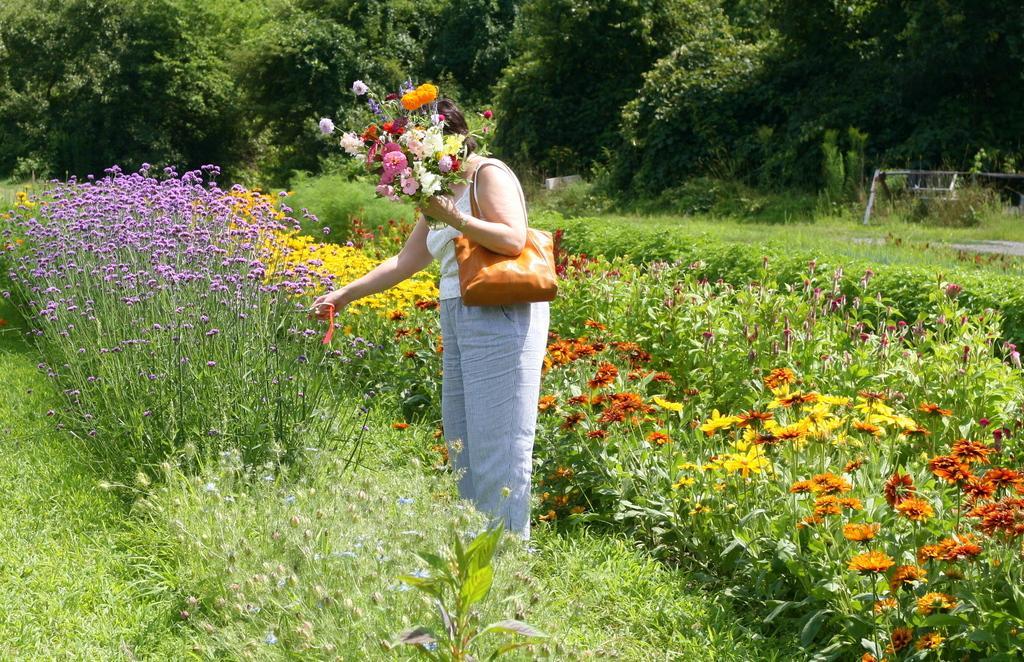Describe this image in one or two sentences. In this image we can see this person wearing white dress and handbag is holding flowers in her hand and standing on the ground. Here we can see the flower plants, grass and the trees in the background. 